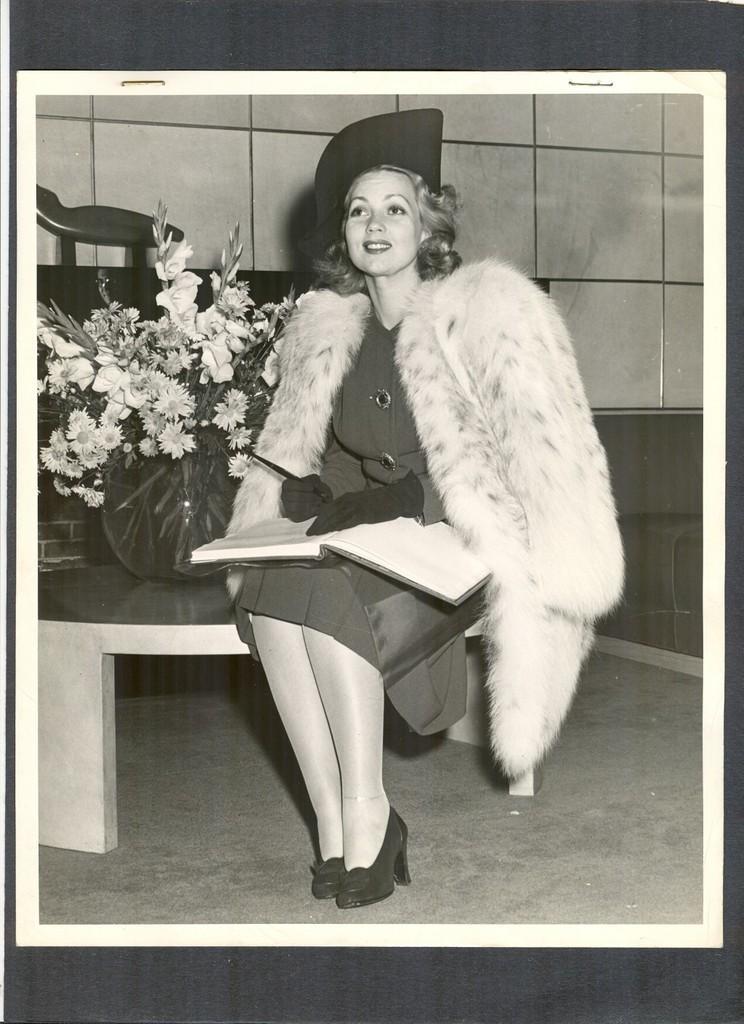Can you describe this image briefly? In this image, we can see the black and white photocopy of a lady holding an object is sitting. We can also see some flowers and an object. We can see the ground and the wall. 